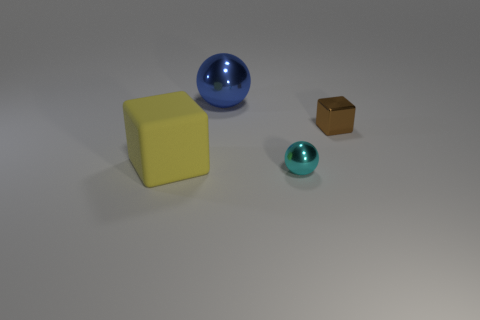What number of yellow matte things are behind the small cyan object?
Your answer should be compact. 1. How many other objects are there of the same size as the brown metallic cube?
Your answer should be very brief. 1. Are the thing on the right side of the tiny metallic ball and the ball in front of the small brown cube made of the same material?
Keep it short and to the point. Yes. There is a rubber thing that is the same size as the blue metallic sphere; what is its color?
Ensure brevity in your answer.  Yellow. Is there any other thing that has the same color as the tiny metallic sphere?
Give a very brief answer. No. What is the size of the block that is to the left of the small thing that is on the right side of the tiny object that is in front of the small metallic cube?
Offer a terse response. Large. What is the color of the thing that is both in front of the blue metallic ball and left of the cyan object?
Your answer should be compact. Yellow. There is a sphere that is in front of the small brown thing; what is its size?
Offer a terse response. Small. How many tiny objects are made of the same material as the big blue sphere?
Your answer should be very brief. 2. There is a object in front of the yellow cube; is its shape the same as the large blue object?
Offer a terse response. Yes. 